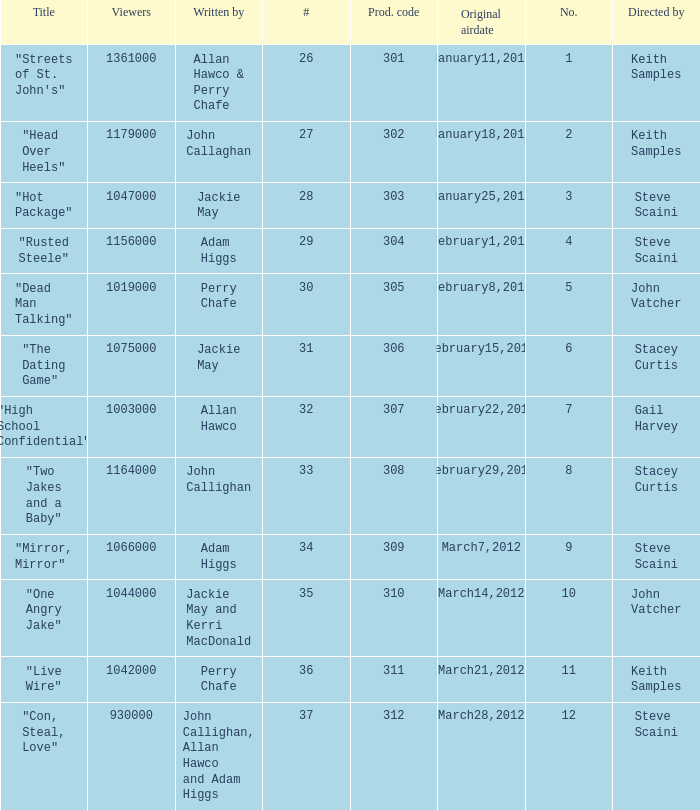What is the number of original airdate written by allan hawco? 1.0. 